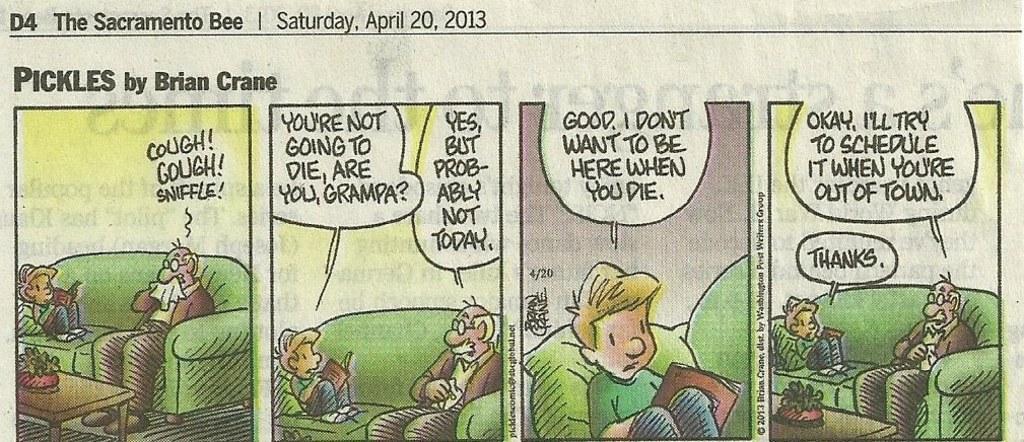In one or two sentences, can you explain what this image depicts? This is a comic column in the newspaper. We can see a man sitting in a sofa and sneezing. There is a boy who is also sitting in a sofa and reading a book. There is a house plant on the table. 